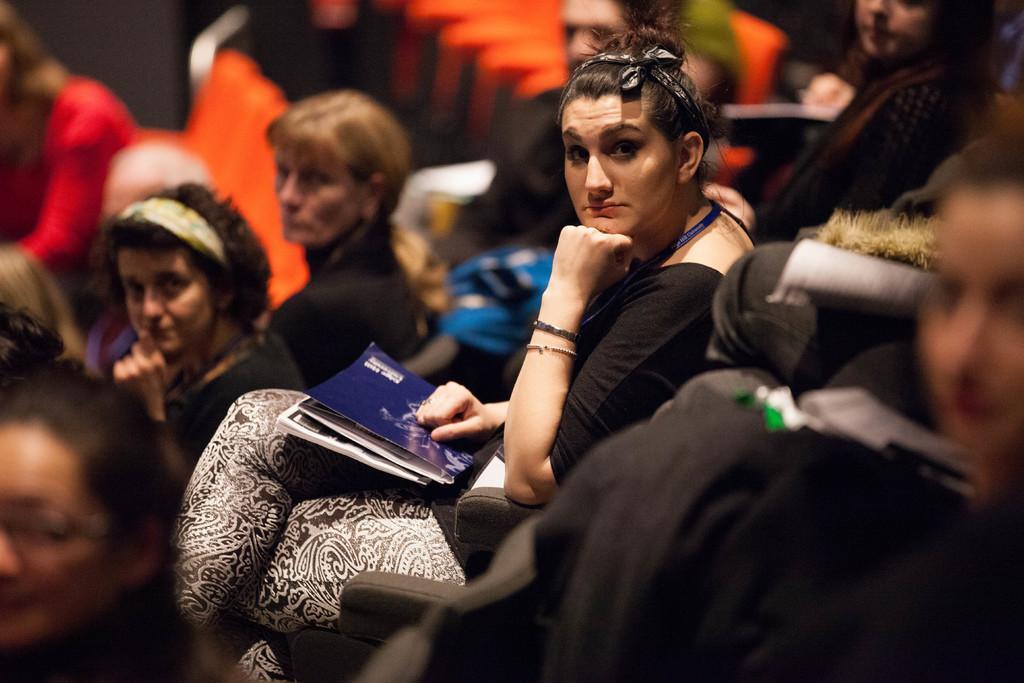Can you describe this image briefly? In this image I can see group of people sitting, the person in front wearing black and white color dress and holding a book which is in blue color. Background I can see chairs in orange color. 